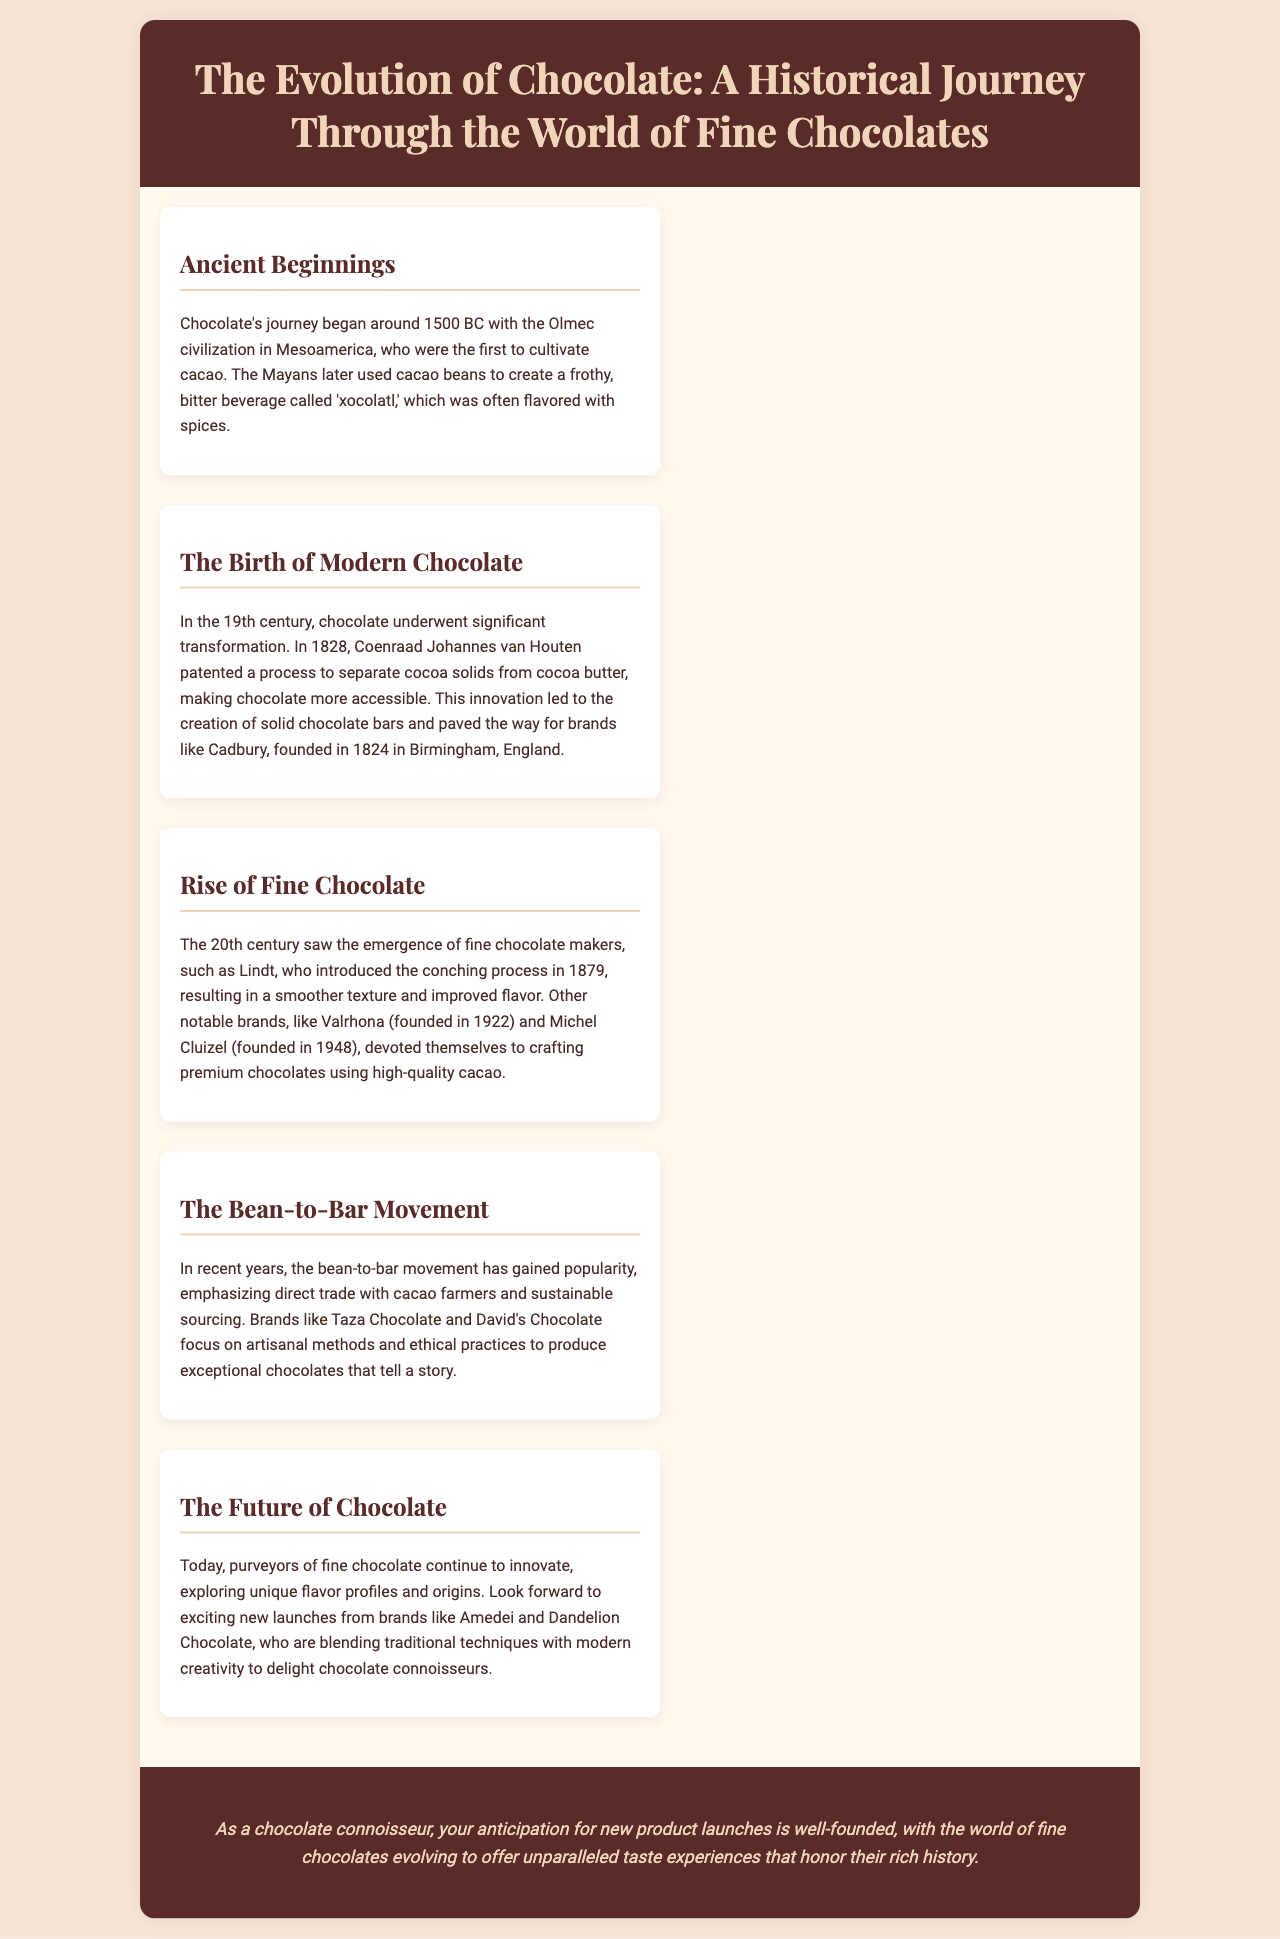What year did the Olmec civilization begin cultivating cacao? The document states that chocolate's journey began around 1500 BC with the Olmec civilization, who were the first to cultivate cacao.
Answer: 1500 BC Who patented the process to separate cocoa solids from cocoa butter? According to the document, Coenraad Johannes van Houten patented the process in 1828.
Answer: Coenraad Johannes van Houten Which brand was founded in 1824 in Birmingham, England? The document mentions that Cadbury was founded in 1824 in Birmingham, England.
Answer: Cadbury What did Lindt introduce in 1879? The document states that Lindt introduced the conching process in 1879, resulting in a smoother texture and improved flavor.
Answer: Conching process What movement emphasizes direct trade with cacao farmers? The document mentions the bean-to-bar movement as emphasizing direct trade with cacao farmers and sustainable sourcing.
Answer: Bean-to-bar Which brand focuses on artisanal methods and ethical practices? The document lists Taza Chocolate as a brand that focuses on artisanal methods and ethical practices.
Answer: Taza Chocolate In which century did fine chocolate makers emerge? The document states that the 20th century saw the emergence of fine chocolate makers.
Answer: 20th century What can we anticipate from brands like Amedei and Dandelion Chocolate? The document indicates that we can look forward to exciting new launches from brands like Amedei and Dandelion Chocolate.
Answer: Exciting new launches 